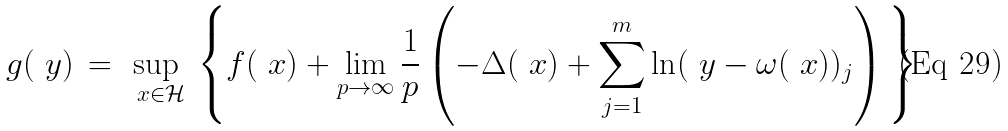Convert formula to latex. <formula><loc_0><loc_0><loc_500><loc_500>g ( \ y ) \, = \, \sup _ { \ x \in \mathcal { H } } \, \left \{ f ( \ x ) + \lim _ { p \to \infty } \frac { 1 } { p } \left ( - \Delta ( \ x ) + \sum _ { j = 1 } ^ { m } \ln ( \ y - \omega ( \ x ) ) _ { j } \right ) \, \right \} .</formula> 